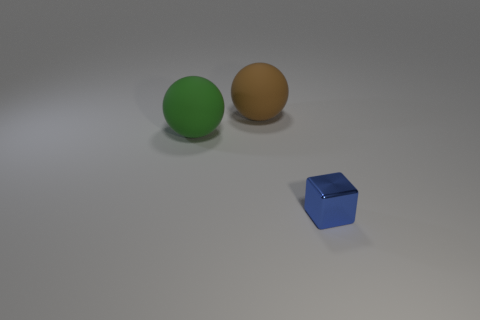Are the green and the brown spheres the same size? Yes, the green and brown spheres appear to be the same size, suggesting they have the same diameter. 